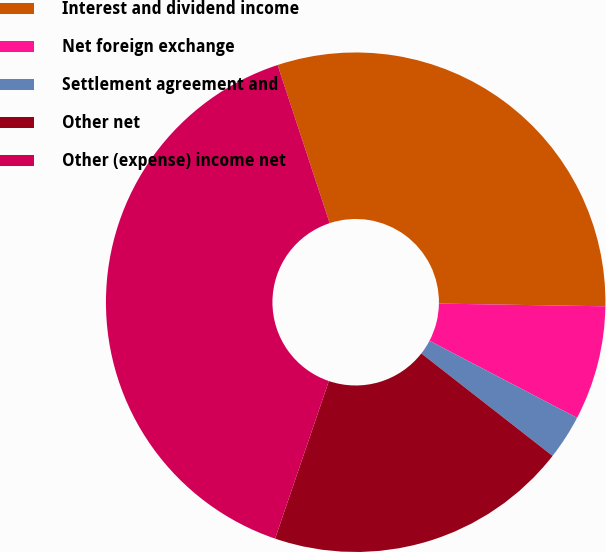Convert chart. <chart><loc_0><loc_0><loc_500><loc_500><pie_chart><fcel>Interest and dividend income<fcel>Net foreign exchange<fcel>Settlement agreement and<fcel>Other net<fcel>Other (expense) income net<nl><fcel>30.32%<fcel>7.4%<fcel>2.89%<fcel>19.68%<fcel>39.71%<nl></chart> 